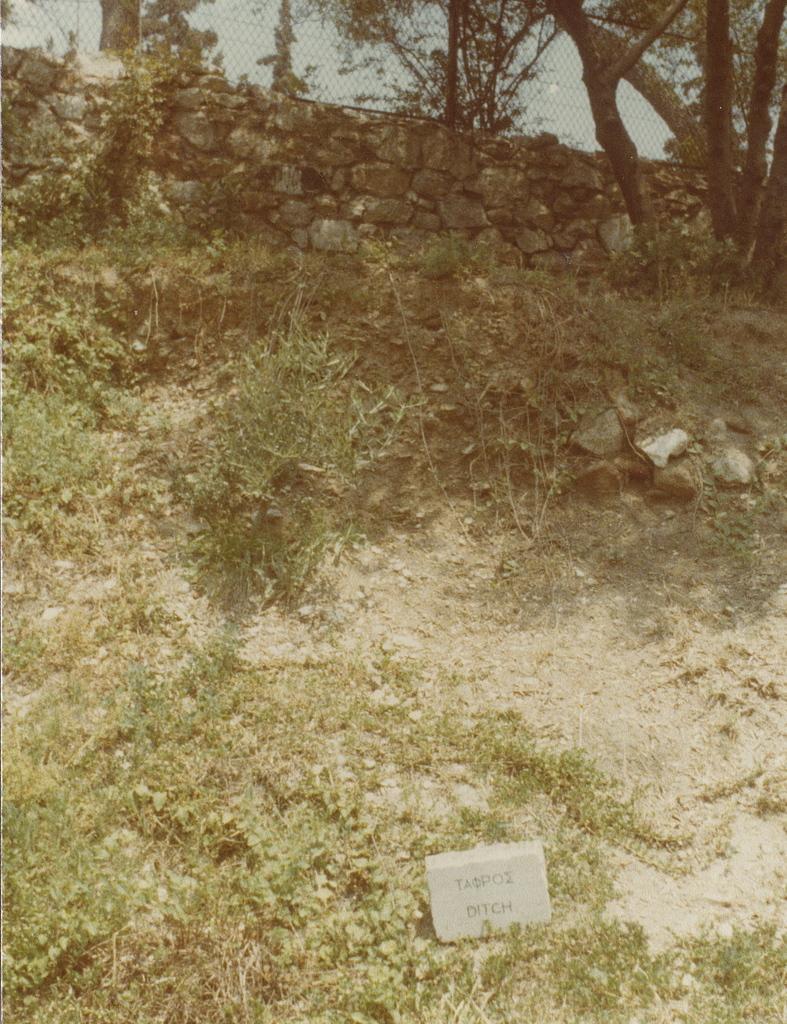Please provide a concise description of this image. In the picture,there is some grass and bushes and in front of that there is a rock wall and beside the rock wall there is a tree and above the wall there is a mesh. 